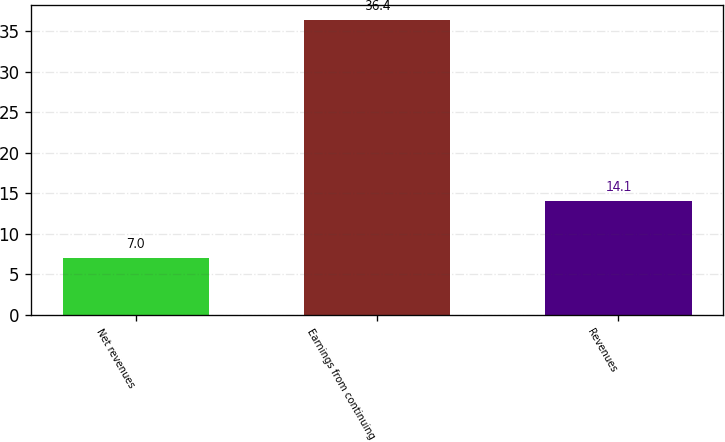<chart> <loc_0><loc_0><loc_500><loc_500><bar_chart><fcel>Net revenues<fcel>Earnings from continuing<fcel>Revenues<nl><fcel>7<fcel>36.4<fcel>14.1<nl></chart> 